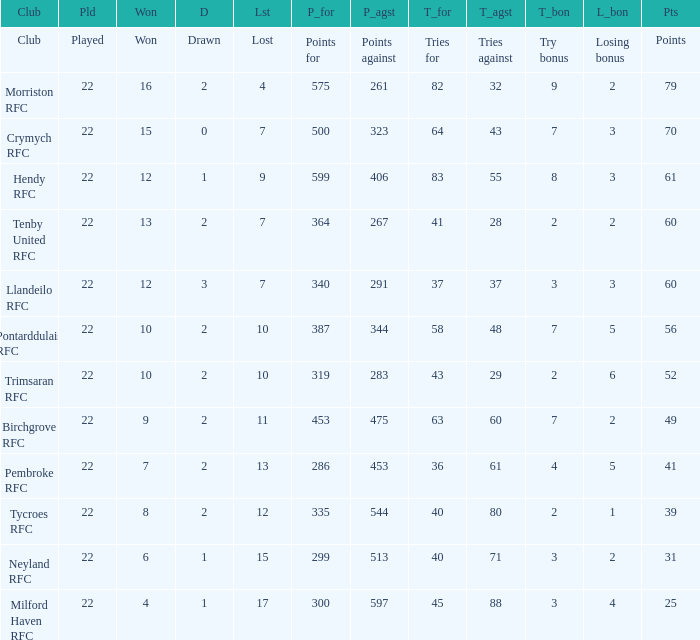 how many losing bonus with won being 10 and points against being 283 1.0. 